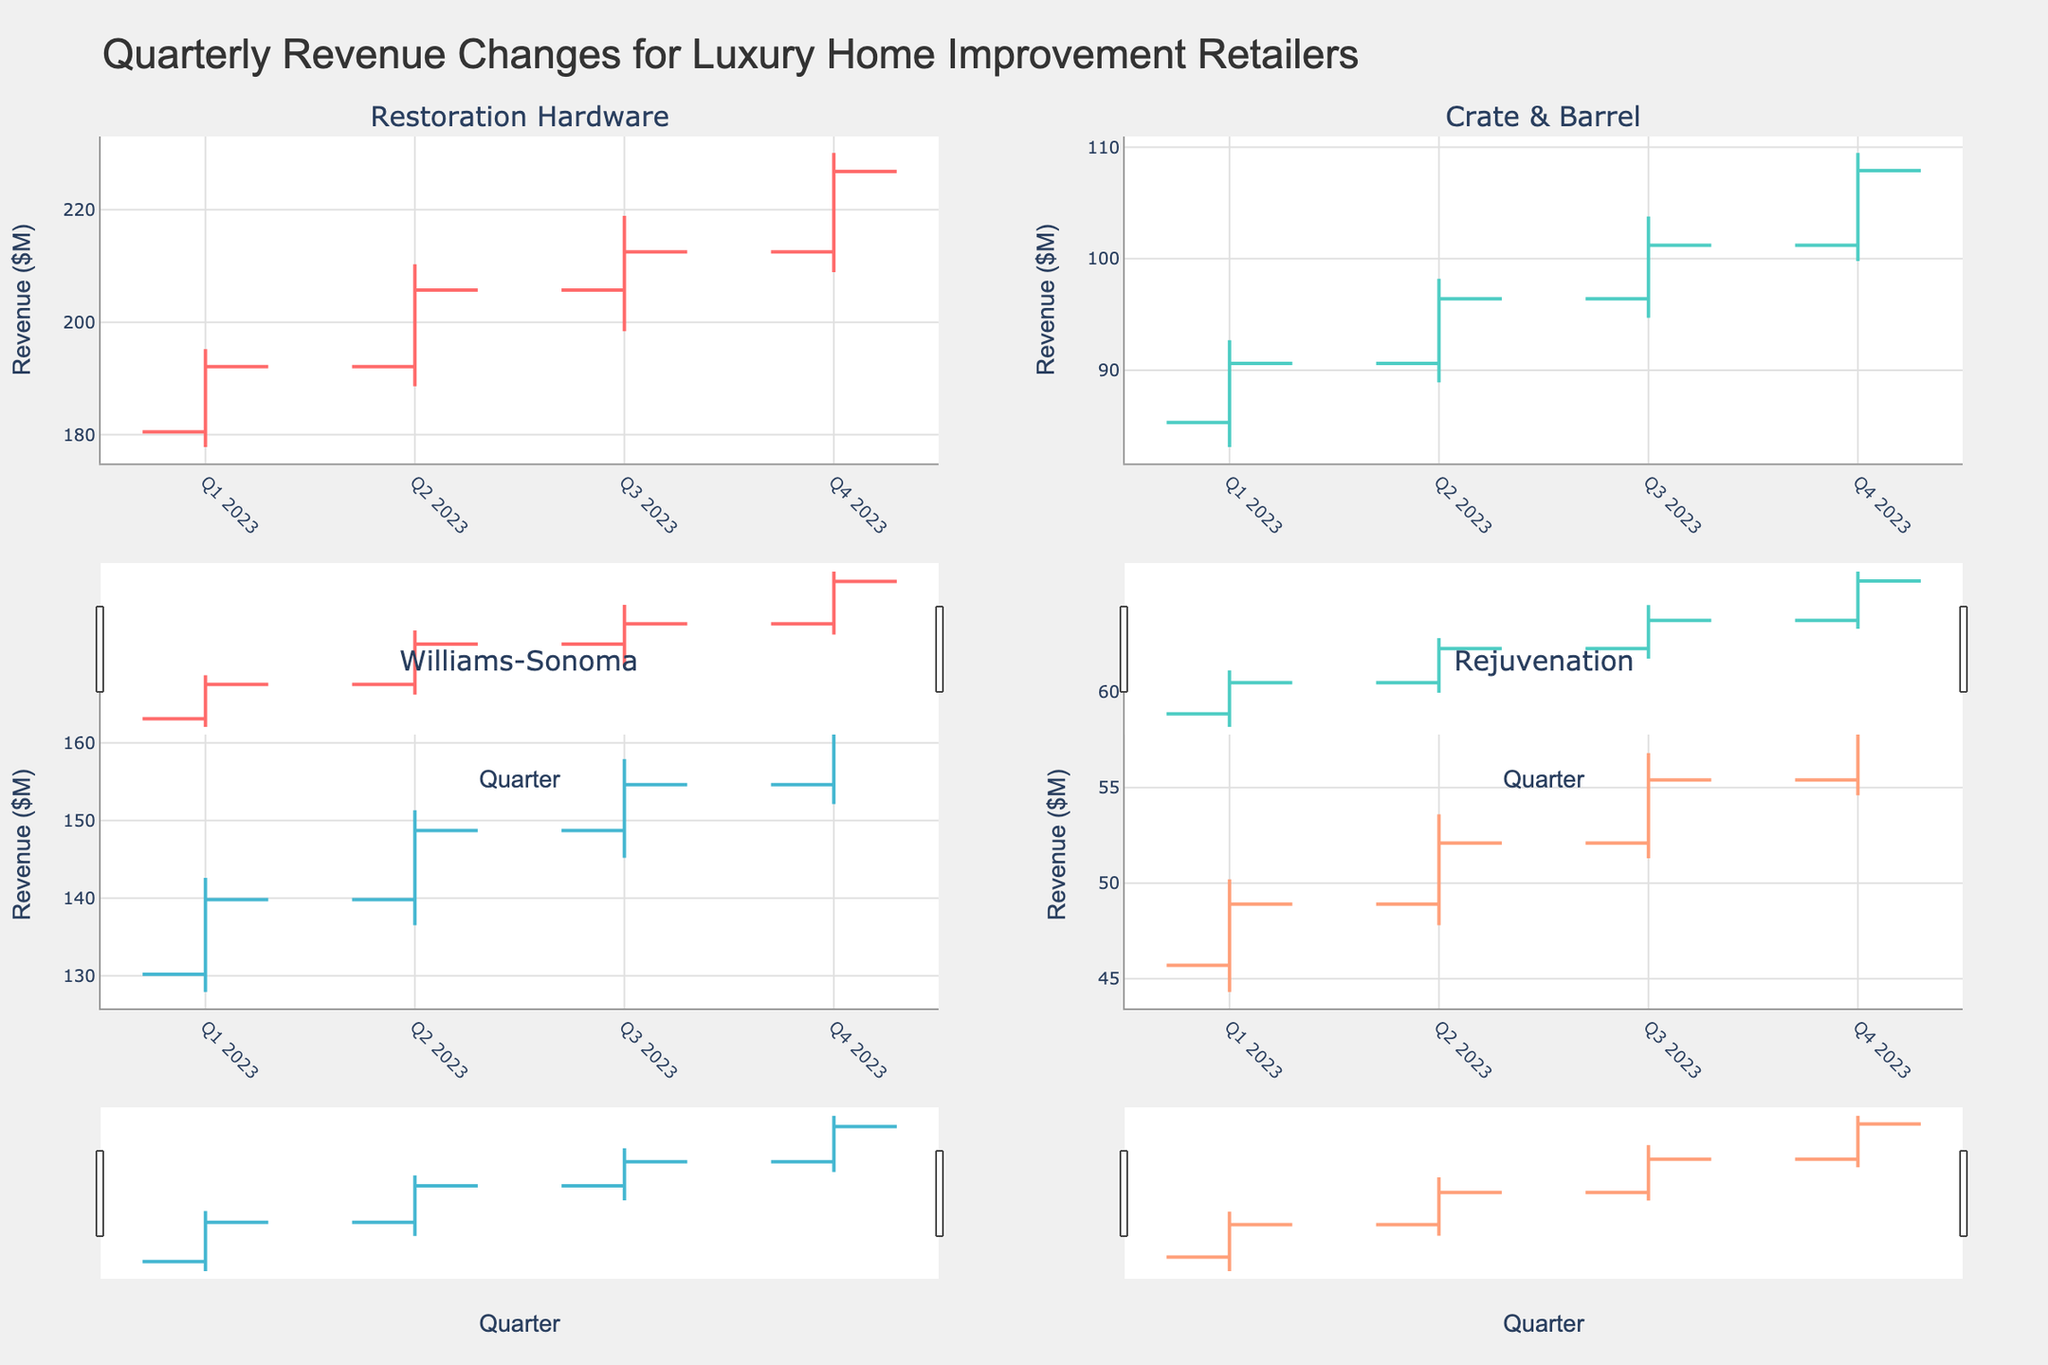What is the title of the figure? The title is located at the top center of the figure. It provides an overview of what the chart represents.
Answer: Quarterly Revenue Changes for Luxury Home Improvement Retailers Which company's revenue saw the highest close value in Q4 2023? Look at the closing values for Q4 2023 in each subplot. Find the highest closing value among the four companies.
Answer: Restoration Hardware What trend can be observed in Restoration Hardware’s quarterly revenue closing values? Look at the closing values for each quarter of 2023 for Restoration Hardware. Identify whether they are increasing or decreasing over time.
Answer: The closing values for Restoration Hardware are steadily increasing Which company experienced a revenue dip between two quarters in 2023, and in which quarters did this happen? Check the closing values between adjacent quarters for each company. Identify any decreases in the closing value and the specific quarters.
Answer: None of the companies experienced a decrease in their closing values between any two consecutive quarters in 2023 